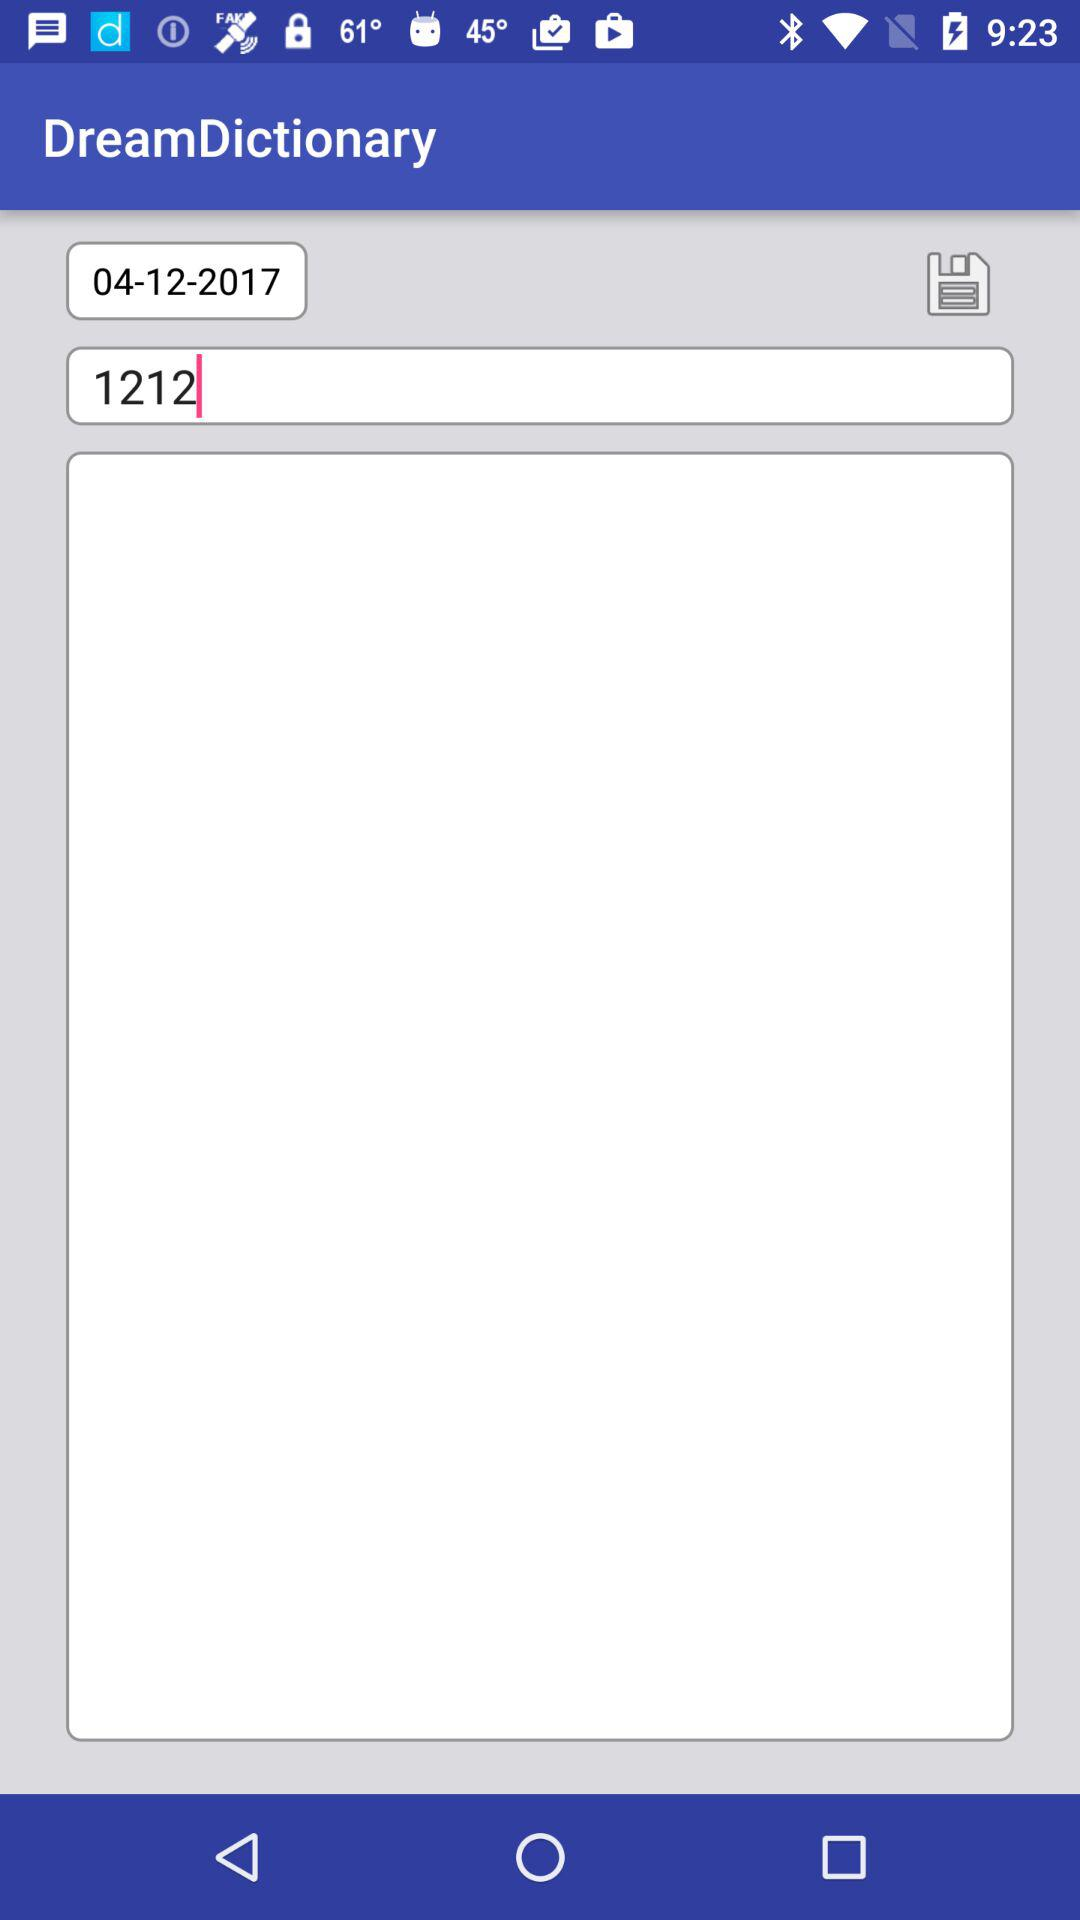What is the entered number? The entered number is 1212. 